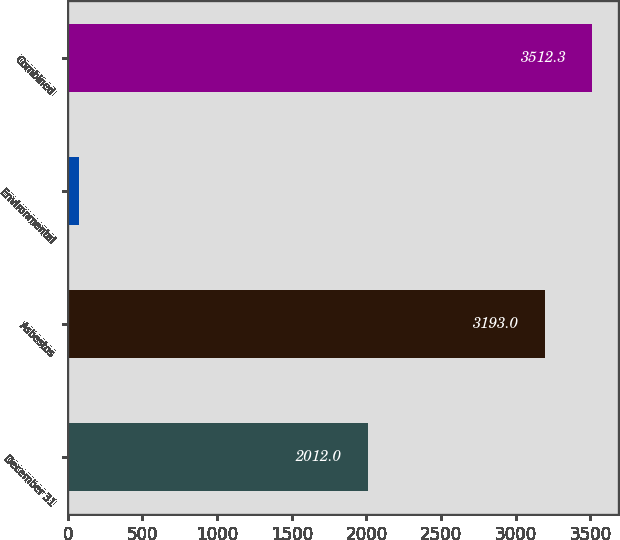<chart> <loc_0><loc_0><loc_500><loc_500><bar_chart><fcel>December 31<fcel>Asbestos<fcel>Environmental<fcel>Combined<nl><fcel>2012<fcel>3193<fcel>75<fcel>3512.3<nl></chart> 